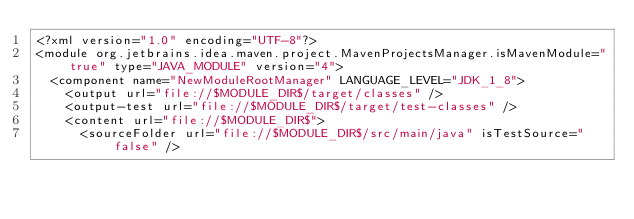<code> <loc_0><loc_0><loc_500><loc_500><_XML_><?xml version="1.0" encoding="UTF-8"?>
<module org.jetbrains.idea.maven.project.MavenProjectsManager.isMavenModule="true" type="JAVA_MODULE" version="4">
  <component name="NewModuleRootManager" LANGUAGE_LEVEL="JDK_1_8">
    <output url="file://$MODULE_DIR$/target/classes" />
    <output-test url="file://$MODULE_DIR$/target/test-classes" />
    <content url="file://$MODULE_DIR$">
      <sourceFolder url="file://$MODULE_DIR$/src/main/java" isTestSource="false" /></code> 